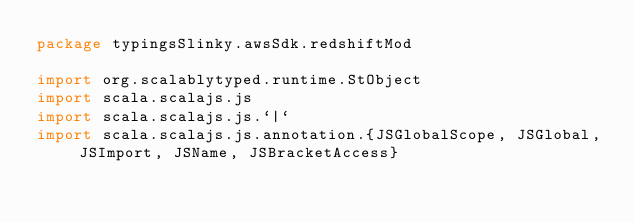Convert code to text. <code><loc_0><loc_0><loc_500><loc_500><_Scala_>package typingsSlinky.awsSdk.redshiftMod

import org.scalablytyped.runtime.StObject
import scala.scalajs.js
import scala.scalajs.js.`|`
import scala.scalajs.js.annotation.{JSGlobalScope, JSGlobal, JSImport, JSName, JSBracketAccess}
</code> 